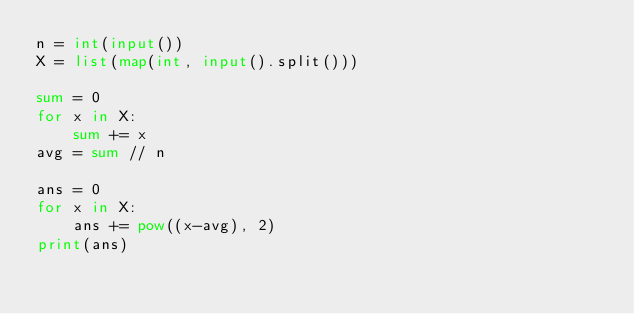Convert code to text. <code><loc_0><loc_0><loc_500><loc_500><_Python_>n = int(input())
X = list(map(int, input().split()))

sum = 0
for x in X:
    sum += x
avg = sum // n

ans = 0
for x in X:
    ans += pow((x-avg), 2)
print(ans)</code> 